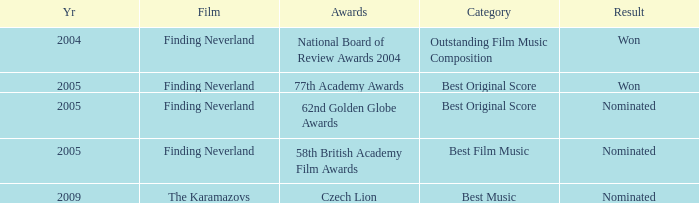What was the result for years prior to 2005? Won. 